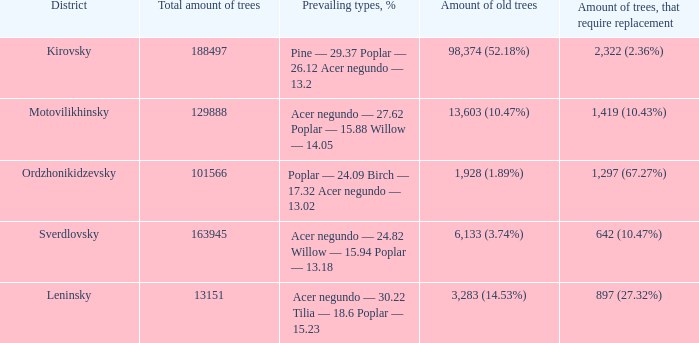Parse the table in full. {'header': ['District', 'Total amount of trees', 'Prevailing types, %', 'Amount of old trees', 'Amount of trees, that require replacement'], 'rows': [['Kirovsky', '188497', 'Pine — 29.37 Poplar — 26.12 Acer negundo — 13.2', '98,374 (52.18%)', '2,322 (2.36%)'], ['Motovilikhinsky', '129888', 'Acer negundo — 27.62 Poplar — 15.88 Willow — 14.05', '13,603 (10.47%)', '1,419 (10.43%)'], ['Ordzhonikidzevsky', '101566', 'Poplar — 24.09 Birch — 17.32 Acer negundo — 13.02', '1,928 (1.89%)', '1,297 (67.27%)'], ['Sverdlovsky', '163945', 'Acer negundo — 24.82 Willow — 15.94 Poplar — 13.18', '6,133 (3.74%)', '642 (10.47%)'], ['Leninsky', '13151', 'Acer negundo — 30.22 Tilia — 18.6 Poplar — 15.23', '3,283 (14.53%)', '897 (27.32%)']]} What is the region when the overall number of trees is less than 15081 Ordzhonikidzevsky. 